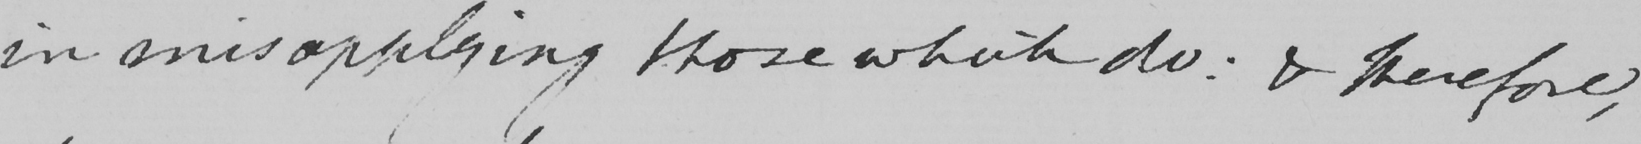Can you read and transcribe this handwriting? in misapplying those which do: & therefore, 